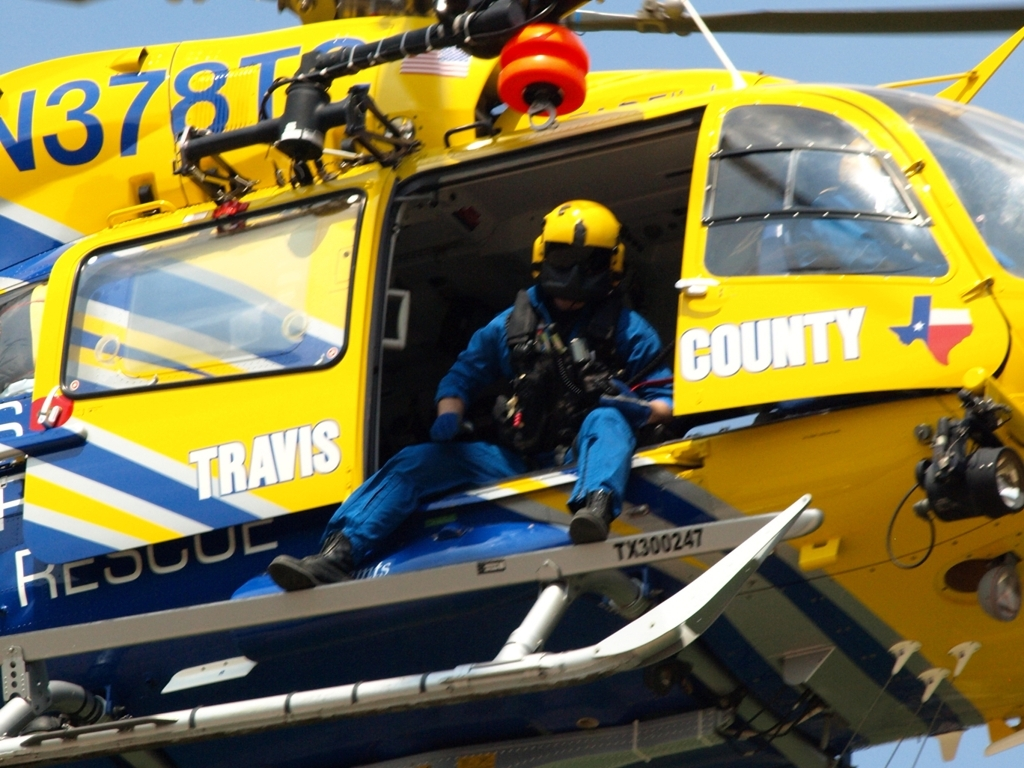What does the evaluation result show? The image is of high quality, presenting high clarity with sharp, discernible details throughout, from the individual elements of the rescue worker's gear to the text and insignias on the helicopter. The edges are crisp, outlining the figures and objects clearly against the backdrop. The colors are indeed vibrant, with the bold yellows and blues of the helicopter providing a visually appealing contrast. 